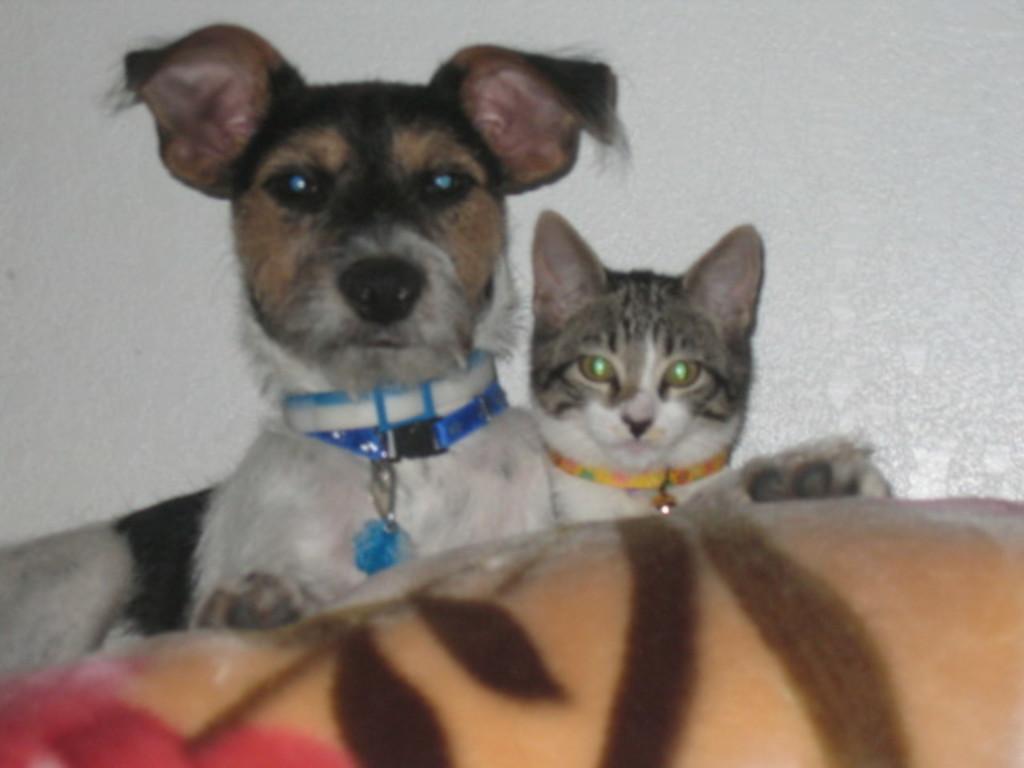Please provide a concise description of this image. in this image there is a dog and a cat. In the background there is white wall. In the foreground there is something. 